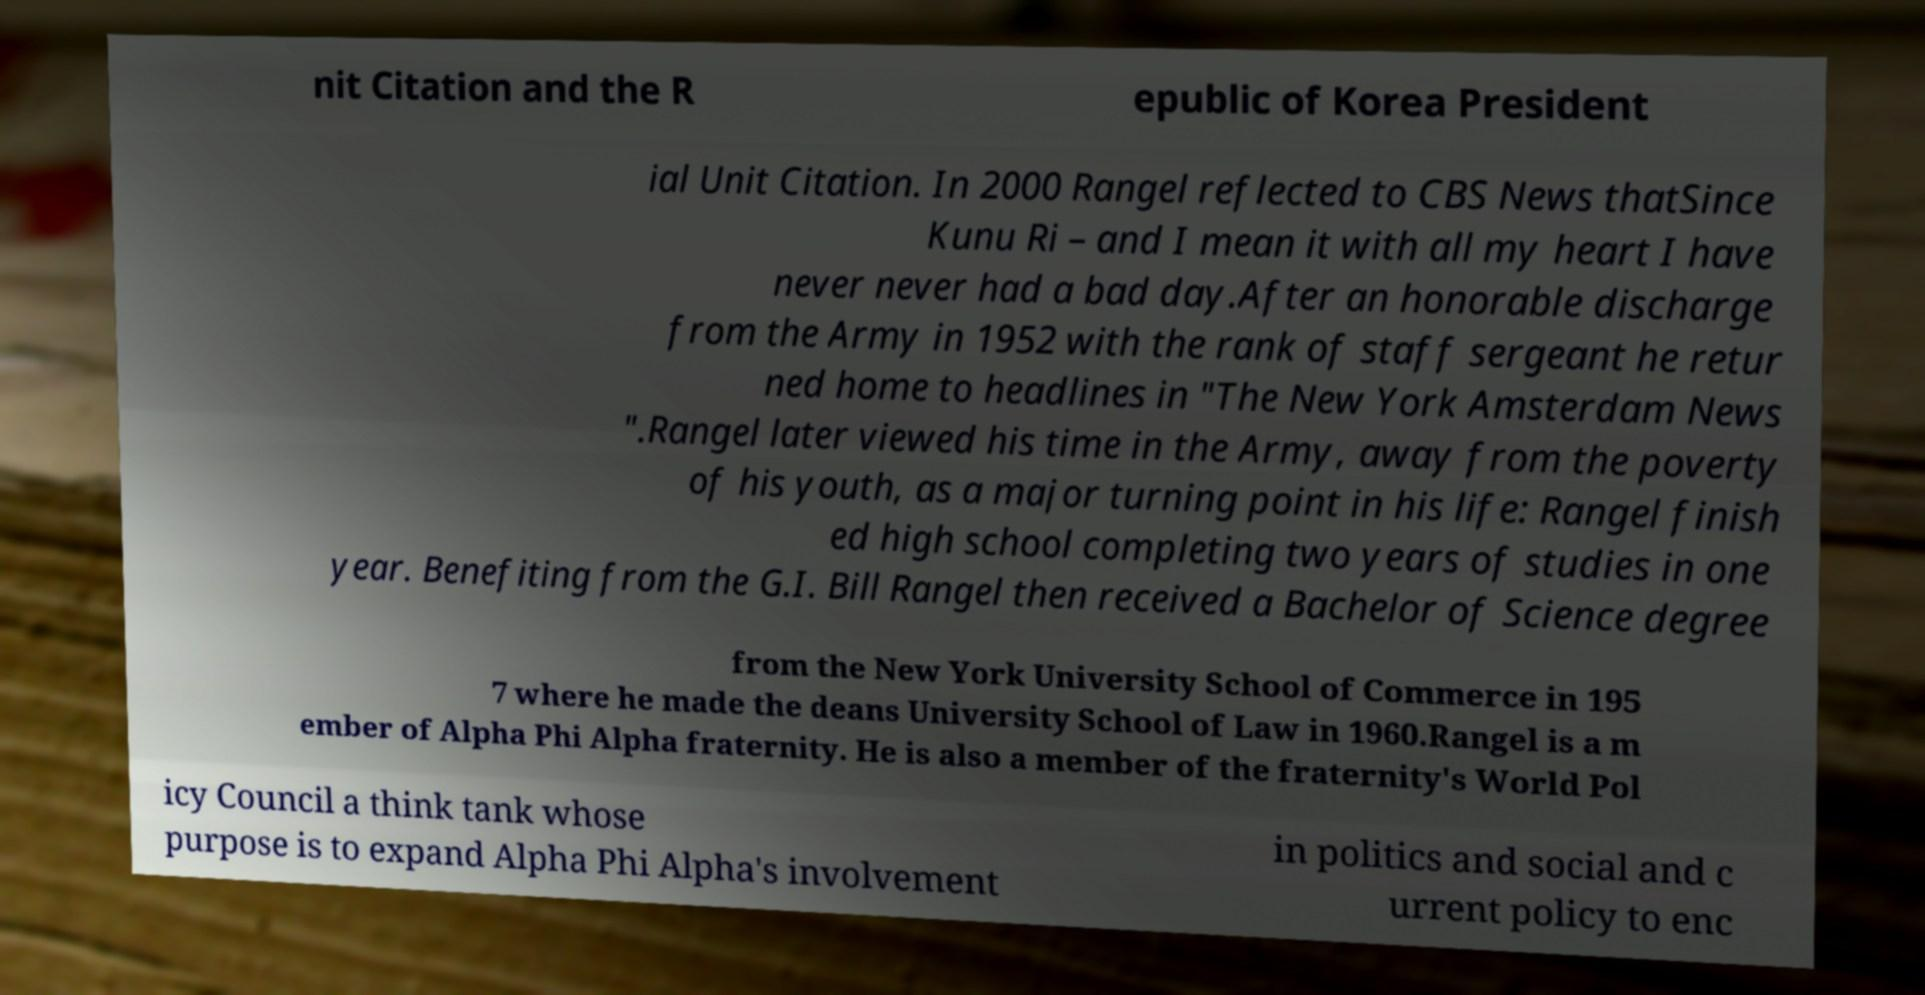Can you read and provide the text displayed in the image?This photo seems to have some interesting text. Can you extract and type it out for me? nit Citation and the R epublic of Korea President ial Unit Citation. In 2000 Rangel reflected to CBS News thatSince Kunu Ri – and I mean it with all my heart I have never never had a bad day.After an honorable discharge from the Army in 1952 with the rank of staff sergeant he retur ned home to headlines in "The New York Amsterdam News ".Rangel later viewed his time in the Army, away from the poverty of his youth, as a major turning point in his life: Rangel finish ed high school completing two years of studies in one year. Benefiting from the G.I. Bill Rangel then received a Bachelor of Science degree from the New York University School of Commerce in 195 7 where he made the deans University School of Law in 1960.Rangel is a m ember of Alpha Phi Alpha fraternity. He is also a member of the fraternity's World Pol icy Council a think tank whose purpose is to expand Alpha Phi Alpha's involvement in politics and social and c urrent policy to enc 